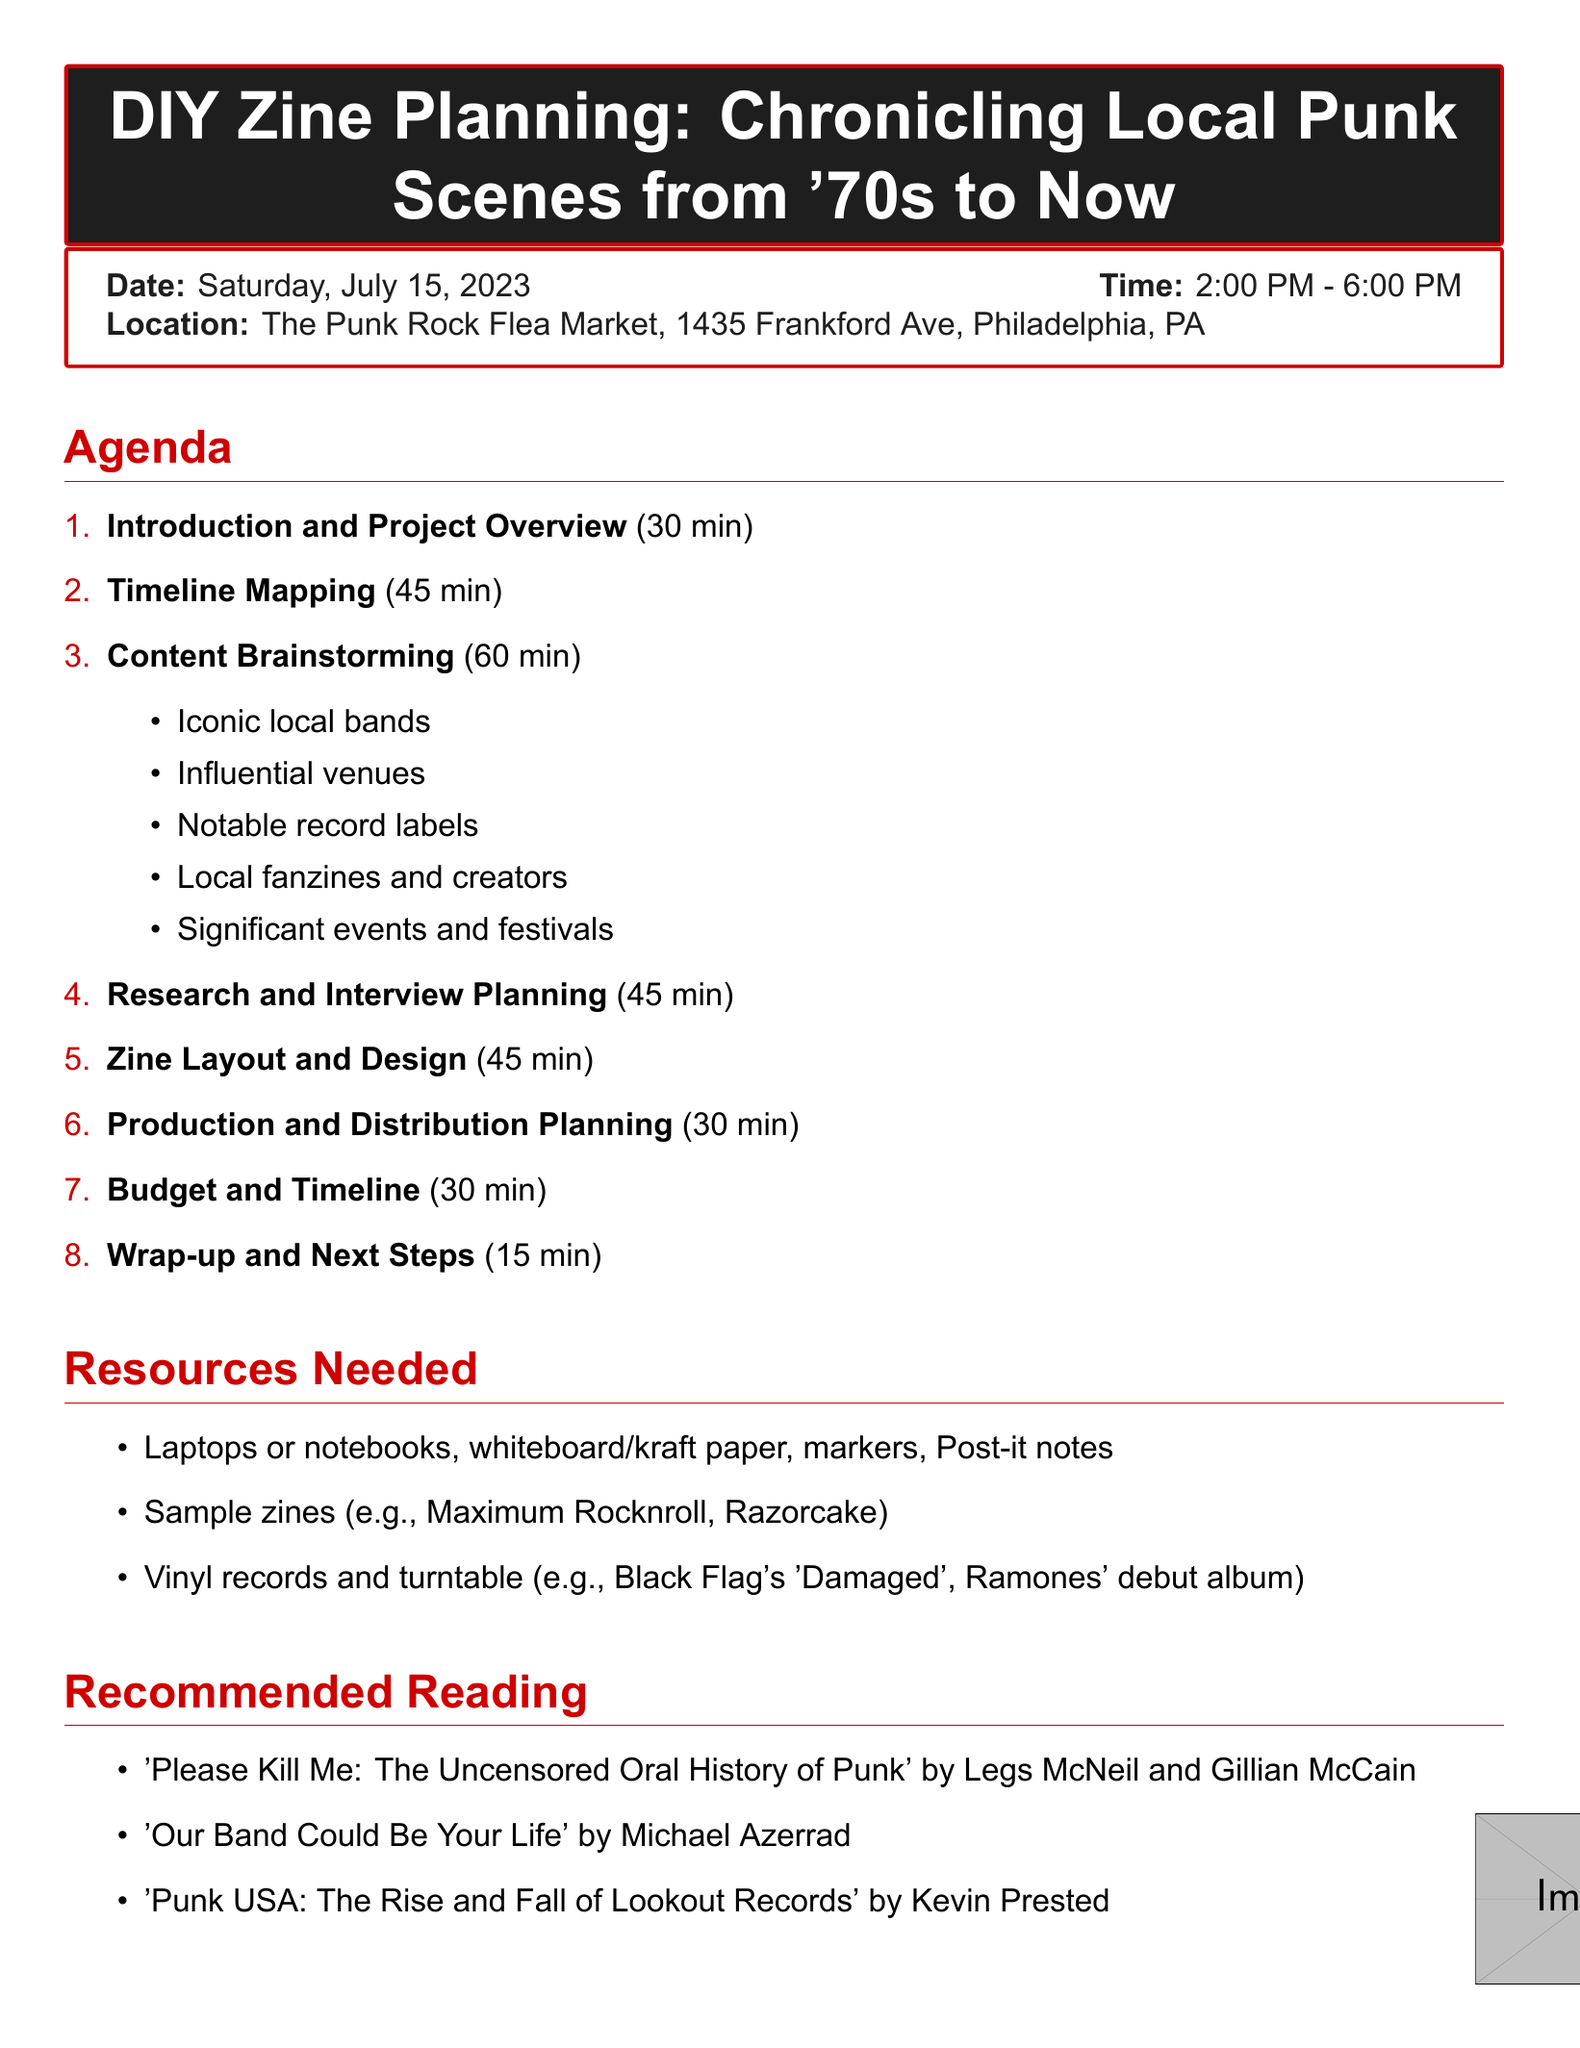What is the title of the planning session? The title is explicitly stated at the beginning of the document, which is "DIY Zine Planning: Chronicling Local Punk Scenes from '70s to Now."
Answer: DIY Zine Planning: Chronicling Local Punk Scenes from '70s to Now When is the planning session scheduled? The date of the session is clearly mentioned, which is Saturday, July 15, 2023.
Answer: Saturday, July 15, 2023 How long is the "Content Brainstorming" segment? The duration for the "Content Brainstorming" segment is specified in the agenda section of the document, indicating 60 minutes.
Answer: 60 minutes What are notable record labels mentioned? The agenda item "Content Brainstorming" lists various topics, including notable record labels, specifically mentioning "Go Kart Records, Jade Tree."
Answer: Go Kart Records, Jade Tree What is the location of the session? The location is given in the details section of the document, which is "The Punk Rock Flea Market, 1435 Frankford Ave, Philadelphia, PA."
Answer: The Punk Rock Flea Market, 1435 Frankford Ave, Philadelphia, PA How many minutes are allocated for "Wrap-up and Next Steps"? The time allocated for the "Wrap-up and Next Steps" is explicitly provided in the agenda, which is 15 minutes.
Answer: 15 minutes What resources are needed for the session? The document specifically lists various resources that are required for the session, including laptops, whiteboard, and sample zines.
Answer: Laptops, whiteboard, sample zines Which book is recommended reading? The document provides a list of recommended readings, one of which is "'Please Kill Me: The Uncensored Oral History of Punk' by Legs McNeil and Gillian McCain."
Answer: 'Please Kill Me: The Uncensored Oral History of Punk' by Legs McNeil and Gillian McCain 